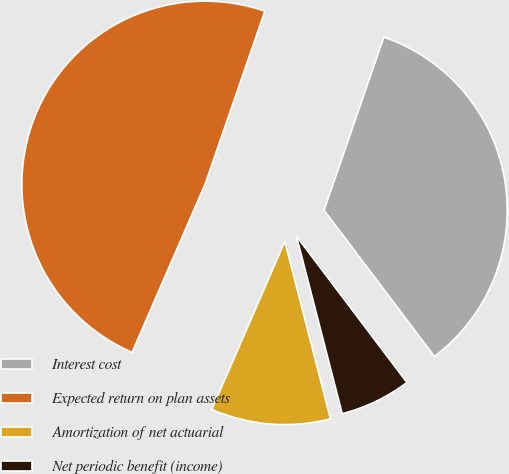Convert chart to OTSL. <chart><loc_0><loc_0><loc_500><loc_500><pie_chart><fcel>Interest cost<fcel>Expected return on plan assets<fcel>Amortization of net actuarial<fcel>Net periodic benefit (income)<nl><fcel>34.41%<fcel>48.77%<fcel>10.53%<fcel>6.28%<nl></chart> 